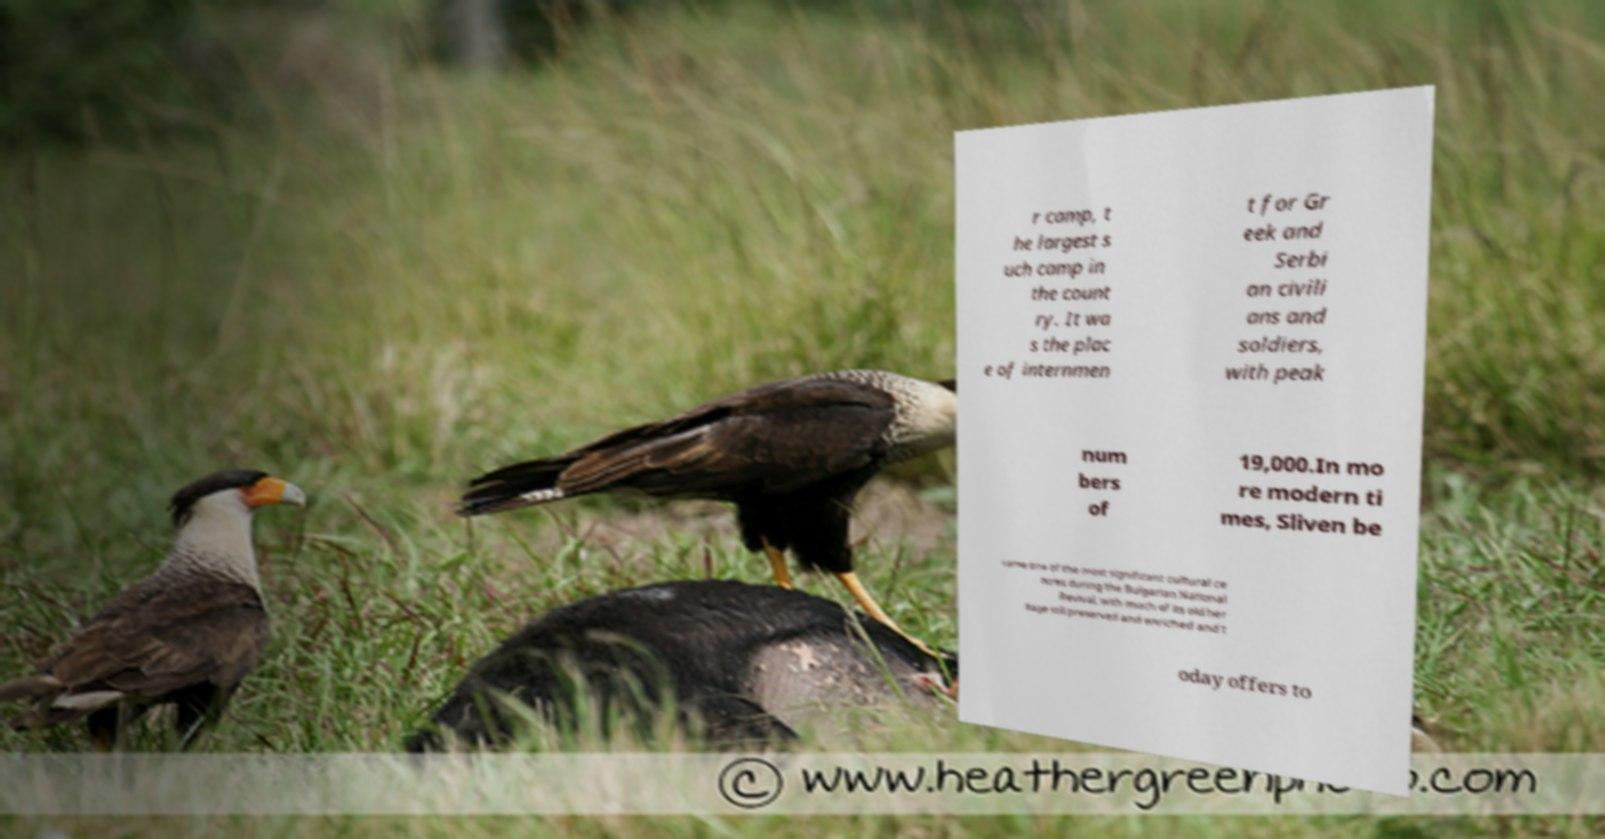What messages or text are displayed in this image? I need them in a readable, typed format. r camp, t he largest s uch camp in the count ry. It wa s the plac e of internmen t for Gr eek and Serbi an civili ans and soldiers, with peak num bers of 19,000.In mo re modern ti mes, Sliven be came one of the most significant cultural ce ntres during the Bulgarian National Revival, with much of its old her itage still preserved and enriched and t oday offers to 